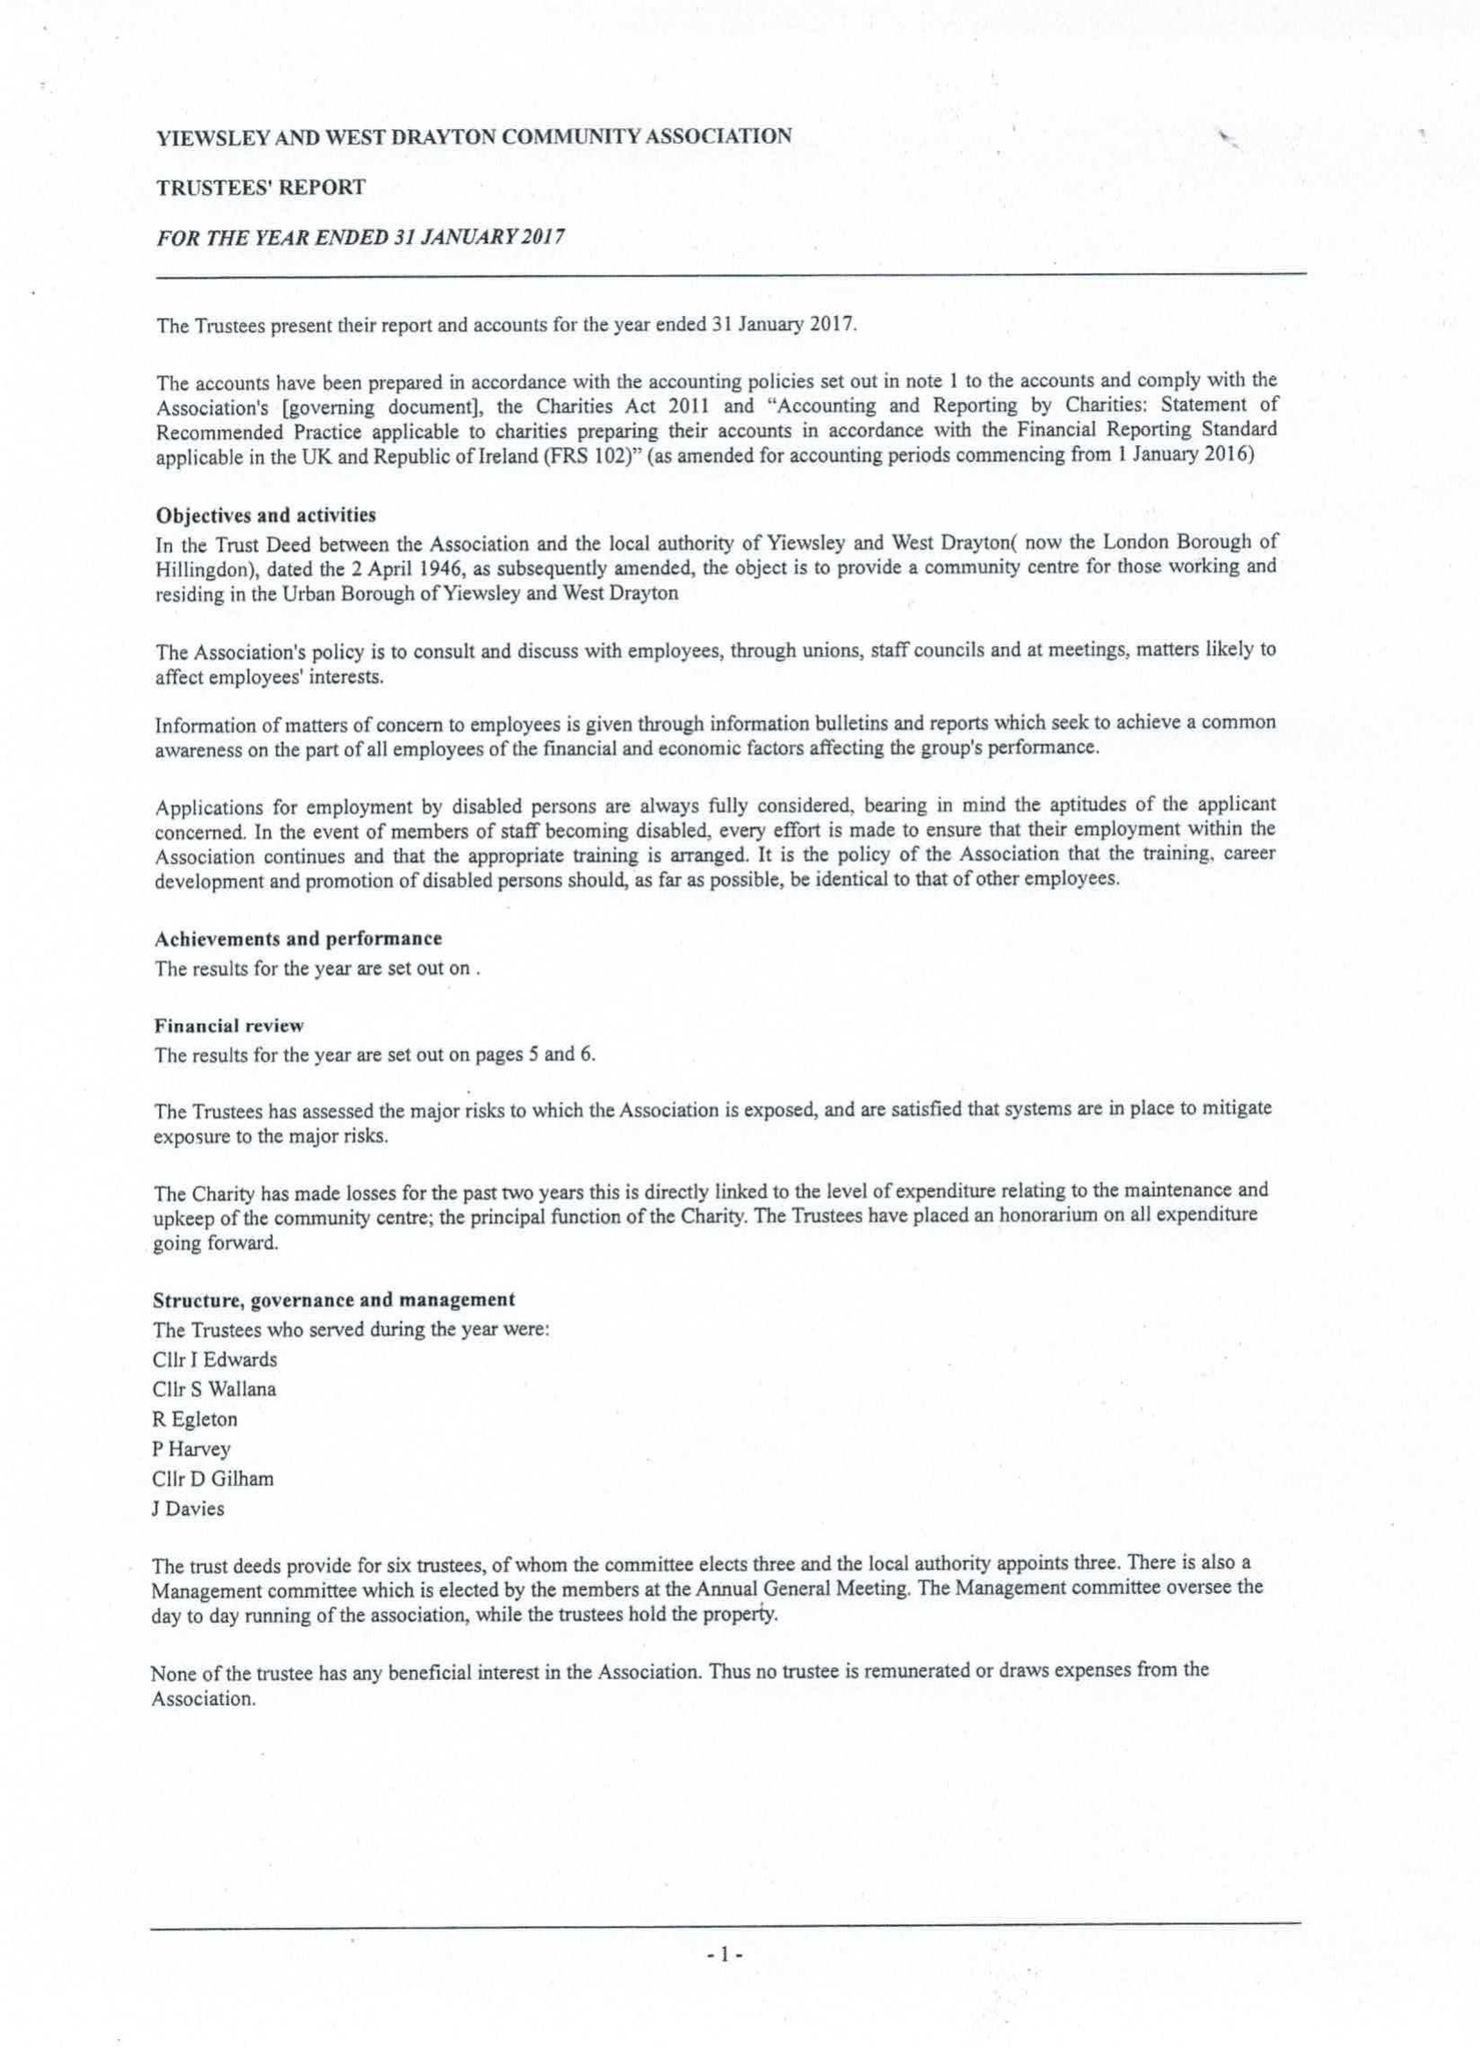What is the value for the address__post_town?
Answer the question using a single word or phrase. WEST DRAYTON 